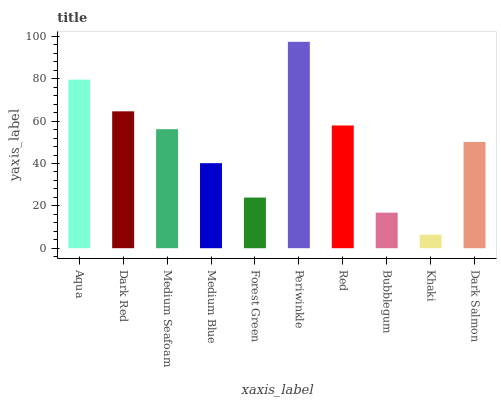Is Khaki the minimum?
Answer yes or no. Yes. Is Periwinkle the maximum?
Answer yes or no. Yes. Is Dark Red the minimum?
Answer yes or no. No. Is Dark Red the maximum?
Answer yes or no. No. Is Aqua greater than Dark Red?
Answer yes or no. Yes. Is Dark Red less than Aqua?
Answer yes or no. Yes. Is Dark Red greater than Aqua?
Answer yes or no. No. Is Aqua less than Dark Red?
Answer yes or no. No. Is Medium Seafoam the high median?
Answer yes or no. Yes. Is Dark Salmon the low median?
Answer yes or no. Yes. Is Aqua the high median?
Answer yes or no. No. Is Forest Green the low median?
Answer yes or no. No. 